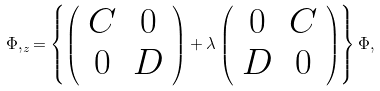<formula> <loc_0><loc_0><loc_500><loc_500>\Phi , _ { z } = \left \{ \left ( \begin{array} { c c } C & 0 \\ 0 & D \end{array} \right ) + \lambda \left ( \begin{array} { c c } 0 & C \\ D & 0 \end{array} \right ) \right \} \Phi ,</formula> 